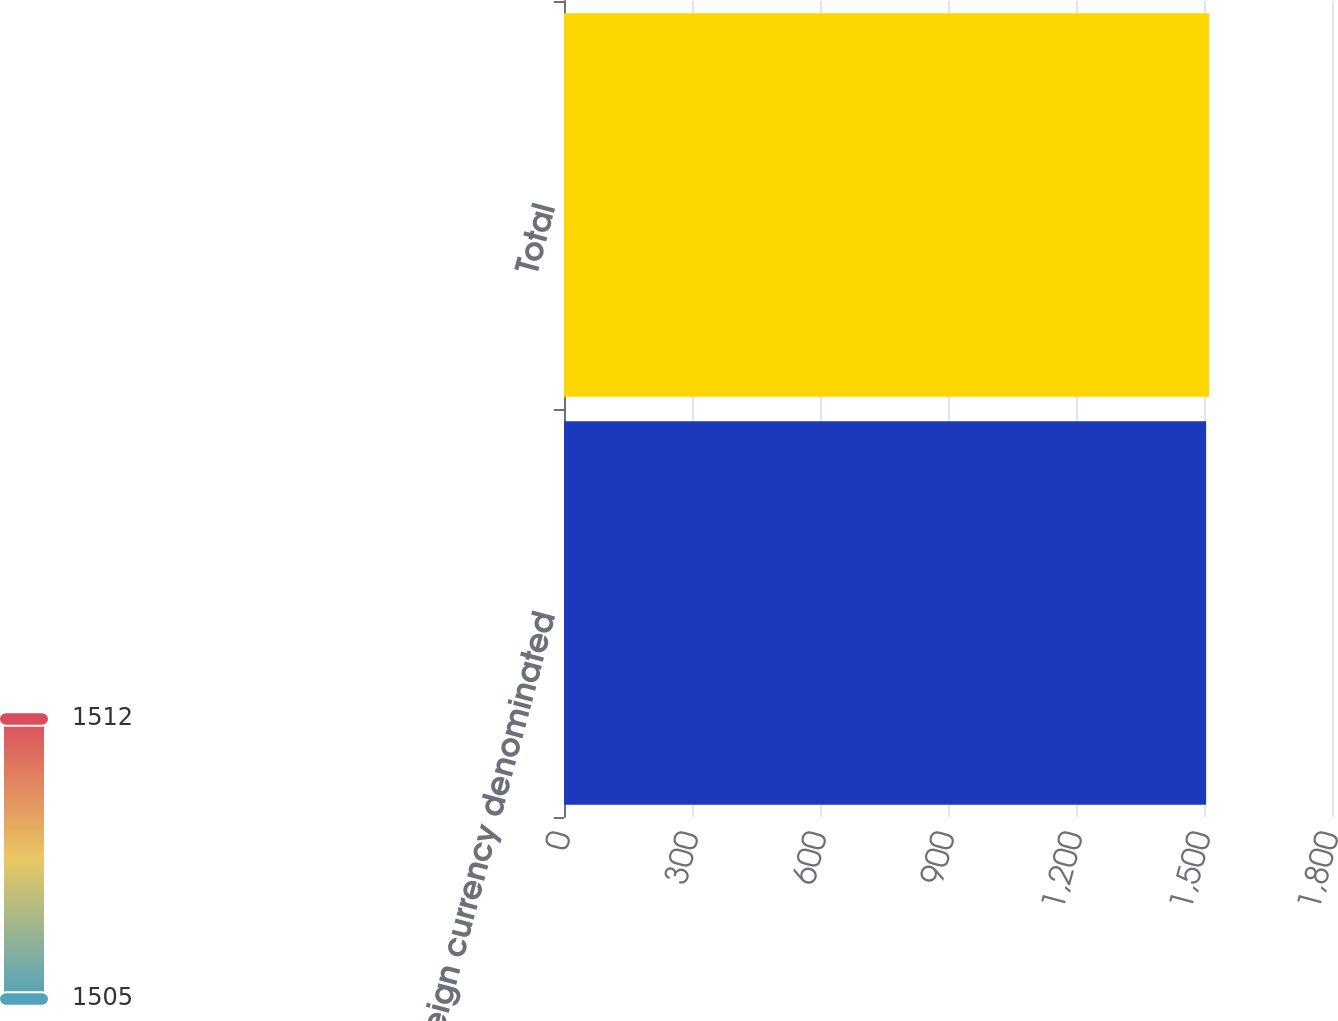<chart> <loc_0><loc_0><loc_500><loc_500><bar_chart><fcel>Foreign currency denominated<fcel>Total<nl><fcel>1505<fcel>1512<nl></chart> 